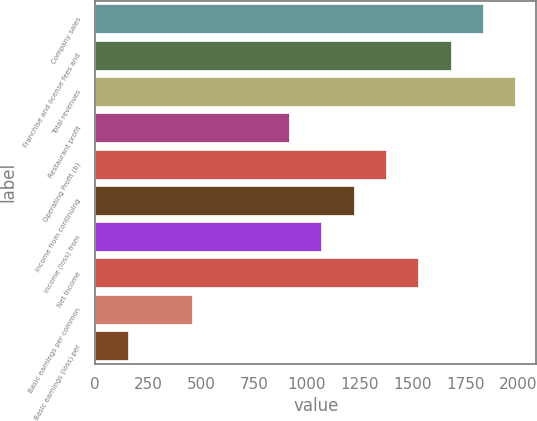Convert chart. <chart><loc_0><loc_0><loc_500><loc_500><bar_chart><fcel>Company sales<fcel>Franchise and license fees and<fcel>Total revenues<fcel>Restaurant profit<fcel>Operating Profit (b)<fcel>Income from continuing<fcel>Income (loss) from<fcel>Net Income<fcel>Basic earnings per common<fcel>Basic earnings (loss) per<nl><fcel>1832.35<fcel>1679.69<fcel>1985.01<fcel>916.39<fcel>1374.37<fcel>1221.71<fcel>1069.05<fcel>1527.03<fcel>458.41<fcel>153.09<nl></chart> 